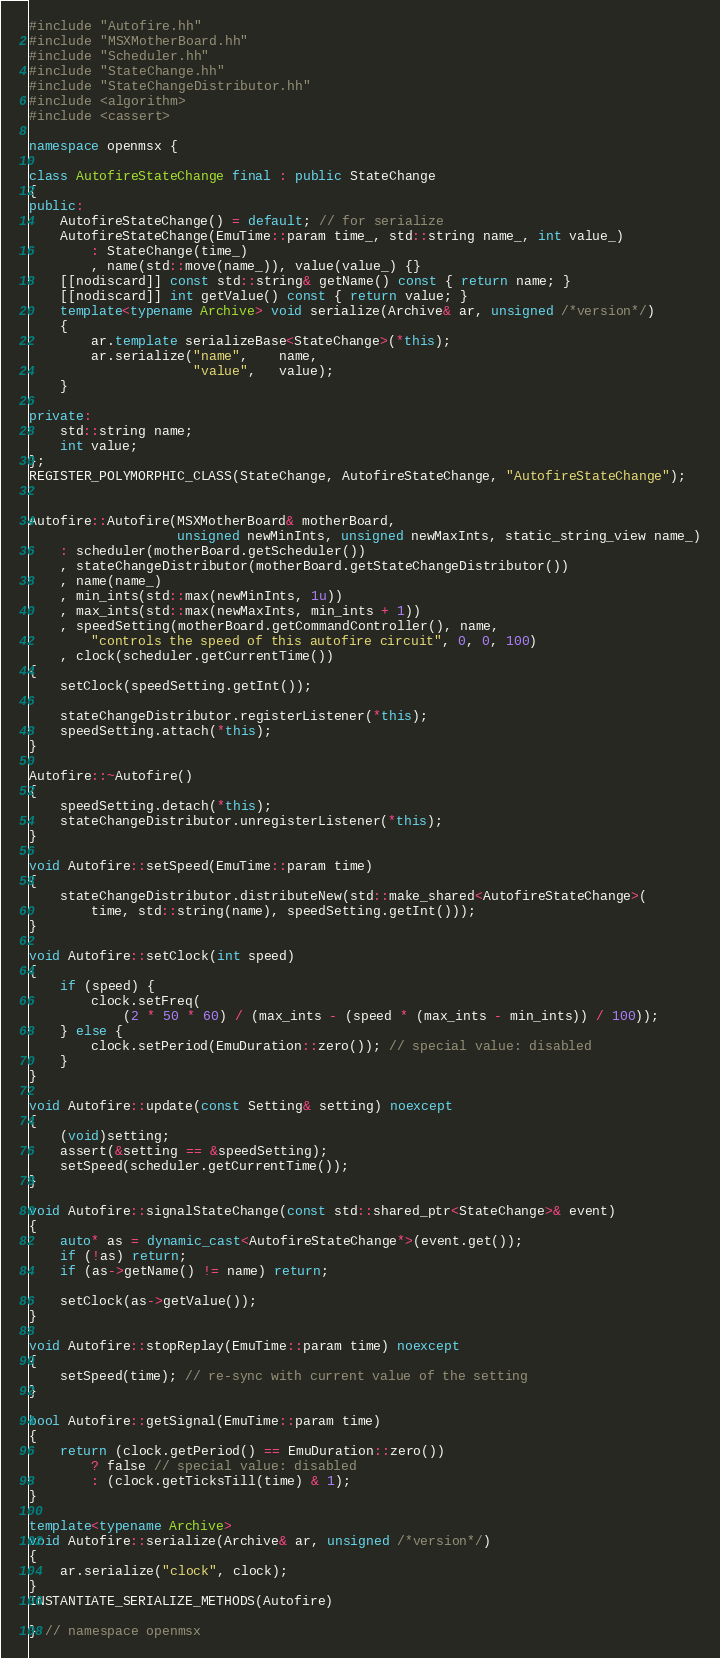Convert code to text. <code><loc_0><loc_0><loc_500><loc_500><_C++_>#include "Autofire.hh"
#include "MSXMotherBoard.hh"
#include "Scheduler.hh"
#include "StateChange.hh"
#include "StateChangeDistributor.hh"
#include <algorithm>
#include <cassert>

namespace openmsx {

class AutofireStateChange final : public StateChange
{
public:
	AutofireStateChange() = default; // for serialize
	AutofireStateChange(EmuTime::param time_, std::string name_, int value_)
		: StateChange(time_)
		, name(std::move(name_)), value(value_) {}
	[[nodiscard]] const std::string& getName() const { return name; }
	[[nodiscard]] int getValue() const { return value; }
	template<typename Archive> void serialize(Archive& ar, unsigned /*version*/)
	{
		ar.template serializeBase<StateChange>(*this);
		ar.serialize("name",    name,
		             "value",   value);
	}

private:
	std::string name;
	int value;
};
REGISTER_POLYMORPHIC_CLASS(StateChange, AutofireStateChange, "AutofireStateChange");


Autofire::Autofire(MSXMotherBoard& motherBoard,
                   unsigned newMinInts, unsigned newMaxInts, static_string_view name_)
	: scheduler(motherBoard.getScheduler())
	, stateChangeDistributor(motherBoard.getStateChangeDistributor())
	, name(name_)
	, min_ints(std::max(newMinInts, 1u))
	, max_ints(std::max(newMaxInts, min_ints + 1))
	, speedSetting(motherBoard.getCommandController(), name,
		"controls the speed of this autofire circuit", 0, 0, 100)
	, clock(scheduler.getCurrentTime())
{
	setClock(speedSetting.getInt());

	stateChangeDistributor.registerListener(*this);
	speedSetting.attach(*this);
}

Autofire::~Autofire()
{
	speedSetting.detach(*this);
	stateChangeDistributor.unregisterListener(*this);
}

void Autofire::setSpeed(EmuTime::param time)
{
	stateChangeDistributor.distributeNew(std::make_shared<AutofireStateChange>(
		time, std::string(name), speedSetting.getInt()));
}

void Autofire::setClock(int speed)
{
	if (speed) {
		clock.setFreq(
		    (2 * 50 * 60) / (max_ints - (speed * (max_ints - min_ints)) / 100));
	} else {
		clock.setPeriod(EmuDuration::zero()); // special value: disabled
	}
}

void Autofire::update(const Setting& setting) noexcept
{
	(void)setting;
	assert(&setting == &speedSetting);
	setSpeed(scheduler.getCurrentTime());
}

void Autofire::signalStateChange(const std::shared_ptr<StateChange>& event)
{
	auto* as = dynamic_cast<AutofireStateChange*>(event.get());
	if (!as) return;
	if (as->getName() != name) return;

	setClock(as->getValue());
}

void Autofire::stopReplay(EmuTime::param time) noexcept
{
	setSpeed(time); // re-sync with current value of the setting
}

bool Autofire::getSignal(EmuTime::param time)
{
	return (clock.getPeriod() == EmuDuration::zero())
		? false // special value: disabled
		: (clock.getTicksTill(time) & 1);
}

template<typename Archive>
void Autofire::serialize(Archive& ar, unsigned /*version*/)
{
	ar.serialize("clock", clock);
}
INSTANTIATE_SERIALIZE_METHODS(Autofire)

} // namespace openmsx
</code> 